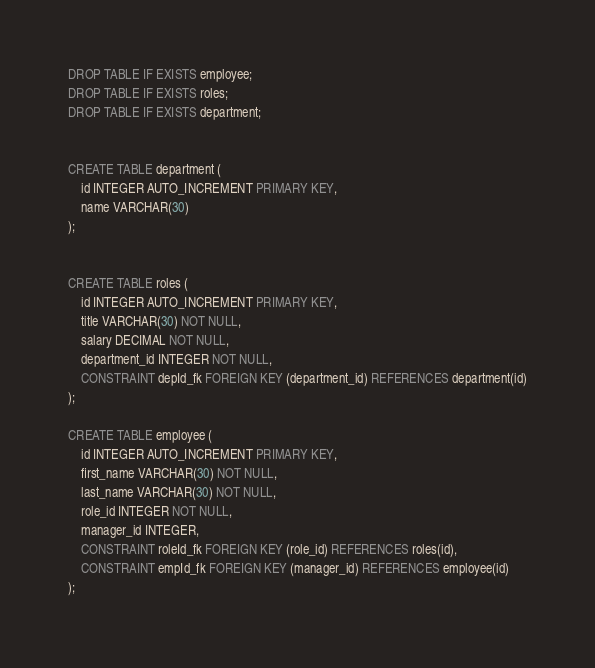Convert code to text. <code><loc_0><loc_0><loc_500><loc_500><_SQL_>DROP TABLE IF EXISTS employee;
DROP TABLE IF EXISTS roles;
DROP TABLE IF EXISTS department;


CREATE TABLE department (
    id INTEGER AUTO_INCREMENT PRIMARY KEY,
    name VARCHAR(30)
);


CREATE TABLE roles (
    id INTEGER AUTO_INCREMENT PRIMARY KEY,
    title VARCHAR(30) NOT NULL,
    salary DECIMAL NOT NULL, 
    department_id INTEGER NOT NULL,
    CONSTRAINT depId_fk FOREIGN KEY (department_id) REFERENCES department(id)
);

CREATE TABLE employee (
    id INTEGER AUTO_INCREMENT PRIMARY KEY,
    first_name VARCHAR(30) NOT NULL,
    last_name VARCHAR(30) NOT NULL, 
    role_id INTEGER NOT NULL,
    manager_id INTEGER, 
    CONSTRAINT roleId_fk FOREIGN KEY (role_id) REFERENCES roles(id),
    CONSTRAINT empId_fk FOREIGN KEY (manager_id) REFERENCES employee(id)
);</code> 